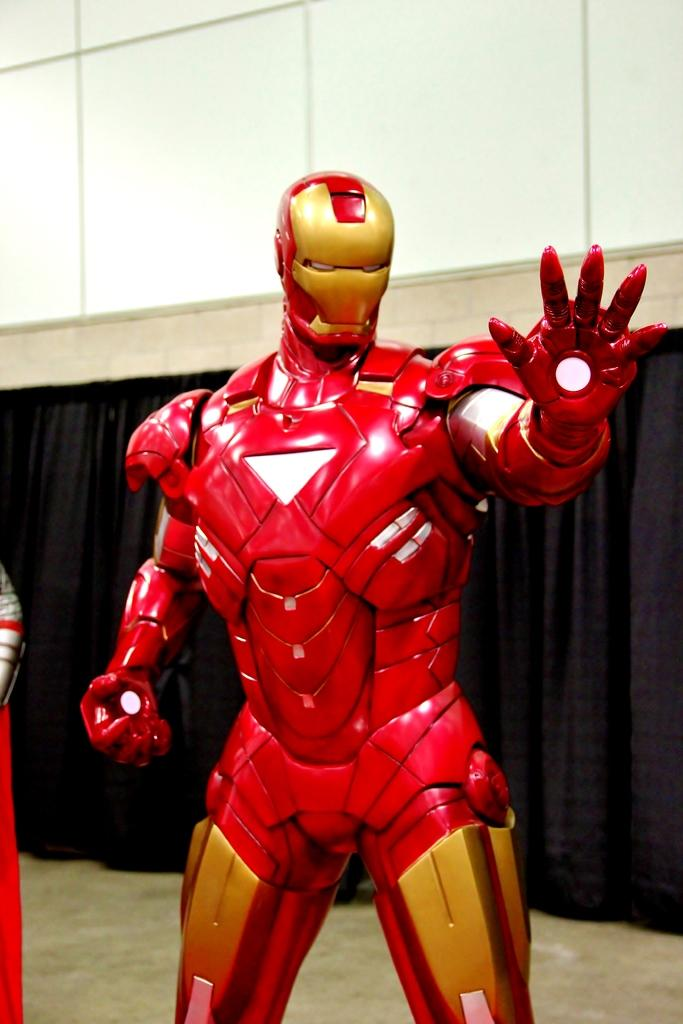What is the main subject in the center of the image? There is a robot in the center of the image. What can be seen in the background of the image? There is a black color curtain in the background of the image. What time or hour is the robot sitting on in the image? The image does not show the robot sitting on a time or hour; it is a robot standing in the center of the image. 